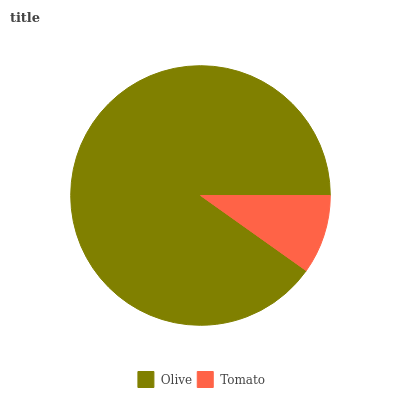Is Tomato the minimum?
Answer yes or no. Yes. Is Olive the maximum?
Answer yes or no. Yes. Is Tomato the maximum?
Answer yes or no. No. Is Olive greater than Tomato?
Answer yes or no. Yes. Is Tomato less than Olive?
Answer yes or no. Yes. Is Tomato greater than Olive?
Answer yes or no. No. Is Olive less than Tomato?
Answer yes or no. No. Is Olive the high median?
Answer yes or no. Yes. Is Tomato the low median?
Answer yes or no. Yes. Is Tomato the high median?
Answer yes or no. No. Is Olive the low median?
Answer yes or no. No. 